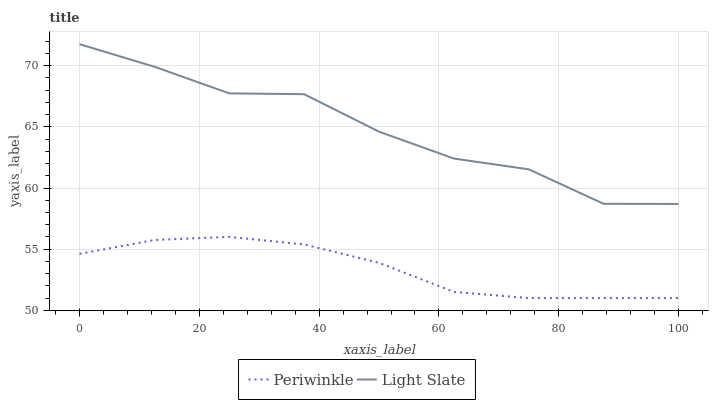Does Periwinkle have the minimum area under the curve?
Answer yes or no. Yes. Does Light Slate have the maximum area under the curve?
Answer yes or no. Yes. Does Periwinkle have the maximum area under the curve?
Answer yes or no. No. Is Periwinkle the smoothest?
Answer yes or no. Yes. Is Light Slate the roughest?
Answer yes or no. Yes. Is Periwinkle the roughest?
Answer yes or no. No. Does Periwinkle have the lowest value?
Answer yes or no. Yes. Does Light Slate have the highest value?
Answer yes or no. Yes. Does Periwinkle have the highest value?
Answer yes or no. No. Is Periwinkle less than Light Slate?
Answer yes or no. Yes. Is Light Slate greater than Periwinkle?
Answer yes or no. Yes. Does Periwinkle intersect Light Slate?
Answer yes or no. No. 